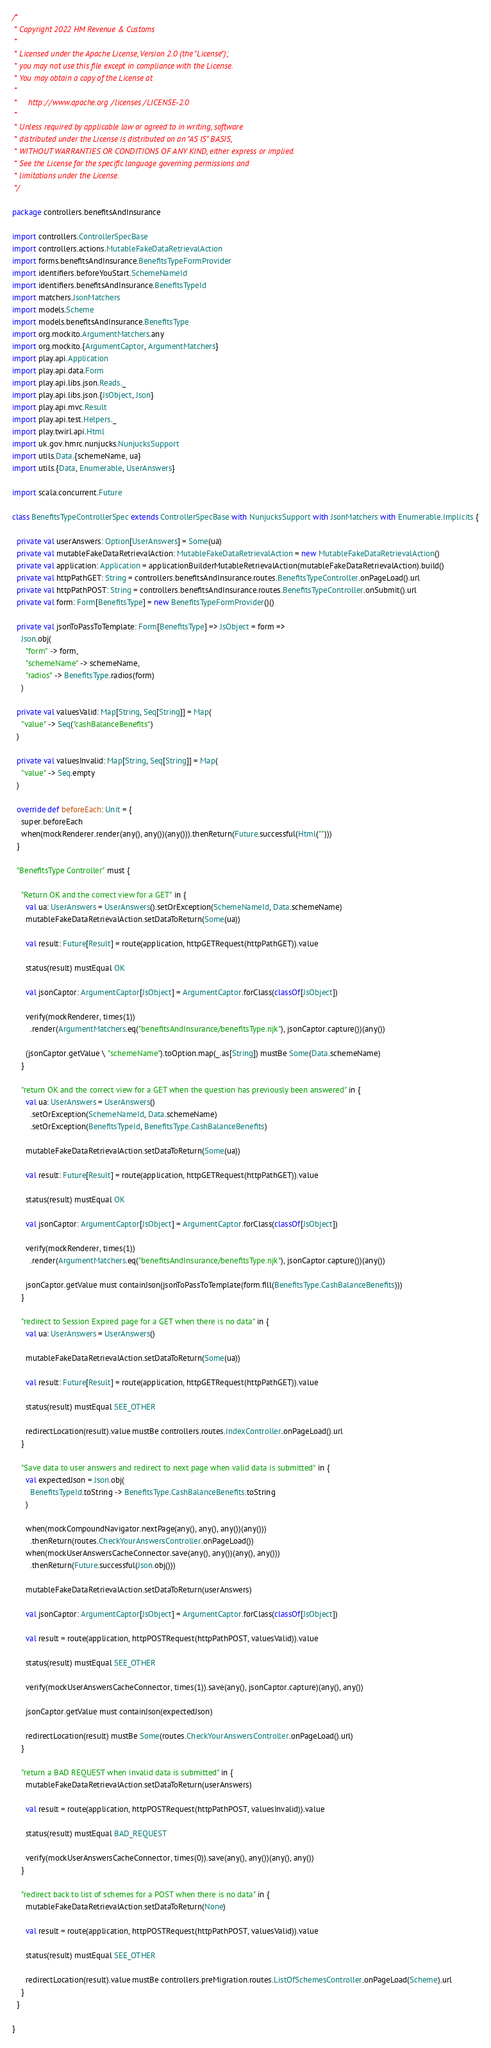Convert code to text. <code><loc_0><loc_0><loc_500><loc_500><_Scala_>/*
 * Copyright 2022 HM Revenue & Customs
 *
 * Licensed under the Apache License, Version 2.0 (the "License");
 * you may not use this file except in compliance with the License.
 * You may obtain a copy of the License at
 *
 *     http://www.apache.org/licenses/LICENSE-2.0
 *
 * Unless required by applicable law or agreed to in writing, software
 * distributed under the License is distributed on an "AS IS" BASIS,
 * WITHOUT WARRANTIES OR CONDITIONS OF ANY KIND, either express or implied.
 * See the License for the specific language governing permissions and
 * limitations under the License.
 */

package controllers.benefitsAndInsurance

import controllers.ControllerSpecBase
import controllers.actions.MutableFakeDataRetrievalAction
import forms.benefitsAndInsurance.BenefitsTypeFormProvider
import identifiers.beforeYouStart.SchemeNameId
import identifiers.benefitsAndInsurance.BenefitsTypeId
import matchers.JsonMatchers
import models.Scheme
import models.benefitsAndInsurance.BenefitsType
import org.mockito.ArgumentMatchers.any
import org.mockito.{ArgumentCaptor, ArgumentMatchers}
import play.api.Application
import play.api.data.Form
import play.api.libs.json.Reads._
import play.api.libs.json.{JsObject, Json}
import play.api.mvc.Result
import play.api.test.Helpers._
import play.twirl.api.Html
import uk.gov.hmrc.nunjucks.NunjucksSupport
import utils.Data.{schemeName, ua}
import utils.{Data, Enumerable, UserAnswers}

import scala.concurrent.Future

class BenefitsTypeControllerSpec extends ControllerSpecBase with NunjucksSupport with JsonMatchers with Enumerable.Implicits {

  private val userAnswers: Option[UserAnswers] = Some(ua)
  private val mutableFakeDataRetrievalAction: MutableFakeDataRetrievalAction = new MutableFakeDataRetrievalAction()
  private val application: Application = applicationBuilderMutableRetrievalAction(mutableFakeDataRetrievalAction).build()
  private val httpPathGET: String = controllers.benefitsAndInsurance.routes.BenefitsTypeController.onPageLoad().url
  private val httpPathPOST: String = controllers.benefitsAndInsurance.routes.BenefitsTypeController.onSubmit().url
  private val form: Form[BenefitsType] = new BenefitsTypeFormProvider()()

  private val jsonToPassToTemplate: Form[BenefitsType] => JsObject = form =>
    Json.obj(
      "form" -> form,
      "schemeName" -> schemeName,
      "radios" -> BenefitsType.radios(form)
    )

  private val valuesValid: Map[String, Seq[String]] = Map(
    "value" -> Seq("cashBalanceBenefits")
  )

  private val valuesInvalid: Map[String, Seq[String]] = Map(
    "value" -> Seq.empty
  )

  override def beforeEach: Unit = {
    super.beforeEach
    when(mockRenderer.render(any(), any())(any())).thenReturn(Future.successful(Html("")))
  }

  "BenefitsType Controller" must {

    "Return OK and the correct view for a GET" in {
      val ua: UserAnswers = UserAnswers().setOrException(SchemeNameId, Data.schemeName)
      mutableFakeDataRetrievalAction.setDataToReturn(Some(ua))

      val result: Future[Result] = route(application, httpGETRequest(httpPathGET)).value

      status(result) mustEqual OK

      val jsonCaptor: ArgumentCaptor[JsObject] = ArgumentCaptor.forClass(classOf[JsObject])

      verify(mockRenderer, times(1))
        .render(ArgumentMatchers.eq("benefitsAndInsurance/benefitsType.njk"), jsonCaptor.capture())(any())

      (jsonCaptor.getValue \ "schemeName").toOption.map(_.as[String]) mustBe Some(Data.schemeName)
    }

    "return OK and the correct view for a GET when the question has previously been answered" in {
      val ua: UserAnswers = UserAnswers()
        .setOrException(SchemeNameId, Data.schemeName)
        .setOrException(BenefitsTypeId, BenefitsType.CashBalanceBenefits)

      mutableFakeDataRetrievalAction.setDataToReturn(Some(ua))

      val result: Future[Result] = route(application, httpGETRequest(httpPathGET)).value

      status(result) mustEqual OK

      val jsonCaptor: ArgumentCaptor[JsObject] = ArgumentCaptor.forClass(classOf[JsObject])

      verify(mockRenderer, times(1))
        .render(ArgumentMatchers.eq("benefitsAndInsurance/benefitsType.njk"), jsonCaptor.capture())(any())

      jsonCaptor.getValue must containJson(jsonToPassToTemplate(form.fill(BenefitsType.CashBalanceBenefits)))
    }

    "redirect to Session Expired page for a GET when there is no data" in {
      val ua: UserAnswers = UserAnswers()

      mutableFakeDataRetrievalAction.setDataToReturn(Some(ua))

      val result: Future[Result] = route(application, httpGETRequest(httpPathGET)).value

      status(result) mustEqual SEE_OTHER

      redirectLocation(result).value mustBe controllers.routes.IndexController.onPageLoad().url
    }

    "Save data to user answers and redirect to next page when valid data is submitted" in {
      val expectedJson = Json.obj(
        BenefitsTypeId.toString -> BenefitsType.CashBalanceBenefits.toString
      )

      when(mockCompoundNavigator.nextPage(any(), any(), any())(any()))
        .thenReturn(routes.CheckYourAnswersController.onPageLoad())
      when(mockUserAnswersCacheConnector.save(any(), any())(any(), any()))
        .thenReturn(Future.successful(Json.obj()))

      mutableFakeDataRetrievalAction.setDataToReturn(userAnswers)

      val jsonCaptor: ArgumentCaptor[JsObject] = ArgumentCaptor.forClass(classOf[JsObject])

      val result = route(application, httpPOSTRequest(httpPathPOST, valuesValid)).value

      status(result) mustEqual SEE_OTHER

      verify(mockUserAnswersCacheConnector, times(1)).save(any(), jsonCaptor.capture)(any(), any())

      jsonCaptor.getValue must containJson(expectedJson)

      redirectLocation(result) mustBe Some(routes.CheckYourAnswersController.onPageLoad().url)
    }

    "return a BAD REQUEST when invalid data is submitted" in {
      mutableFakeDataRetrievalAction.setDataToReturn(userAnswers)

      val result = route(application, httpPOSTRequest(httpPathPOST, valuesInvalid)).value

      status(result) mustEqual BAD_REQUEST

      verify(mockUserAnswersCacheConnector, times(0)).save(any(), any())(any(), any())
    }

    "redirect back to list of schemes for a POST when there is no data" in {
      mutableFakeDataRetrievalAction.setDataToReturn(None)

      val result = route(application, httpPOSTRequest(httpPathPOST, valuesValid)).value

      status(result) mustEqual SEE_OTHER

      redirectLocation(result).value mustBe controllers.preMigration.routes.ListOfSchemesController.onPageLoad(Scheme).url
    }
  }

}
</code> 